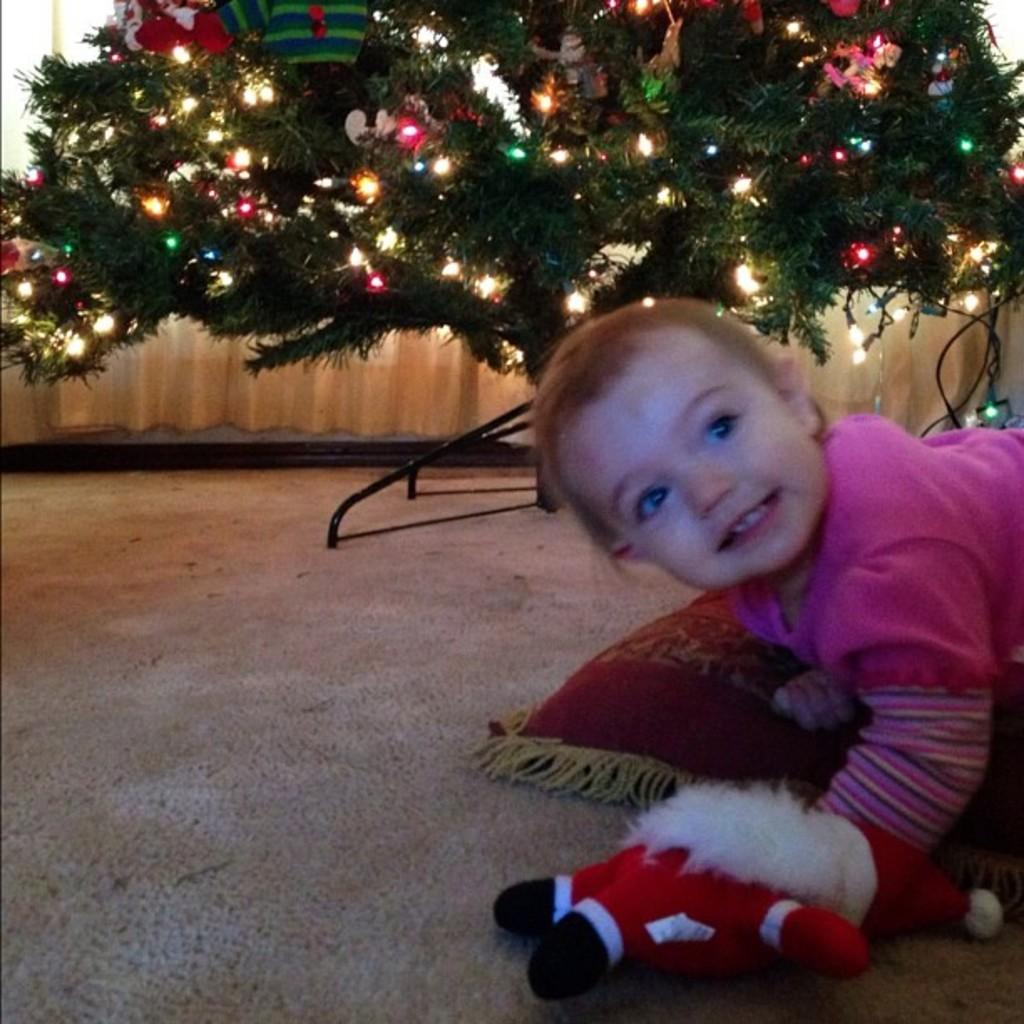What is the main subject of the image? There is a baby in the image. What is located near the baby? There is a pillow in the image. What other object can be seen on the floor in the image? There is a doll on the floor in the image. What can be seen in the background of the image? There is a tree with lights, toys on the tree, a stand, and curtains in the background of the image. How many mice are playing with the toys on the tree in the background of the image? There are no mice present in the image; only the baby, pillow, doll, tree with lights, toys on the tree, stand, and curtains can be seen. 